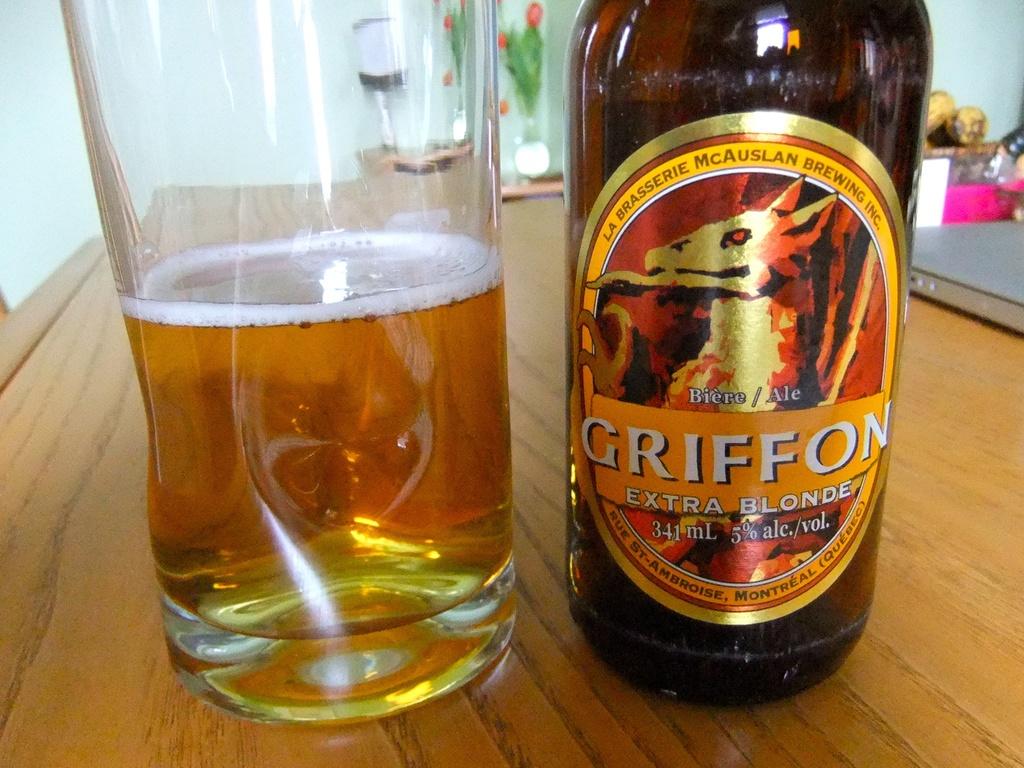What is the brand of this drink?
Ensure brevity in your answer.  Griffon. What is extra about it?
Provide a short and direct response. Blonde. 